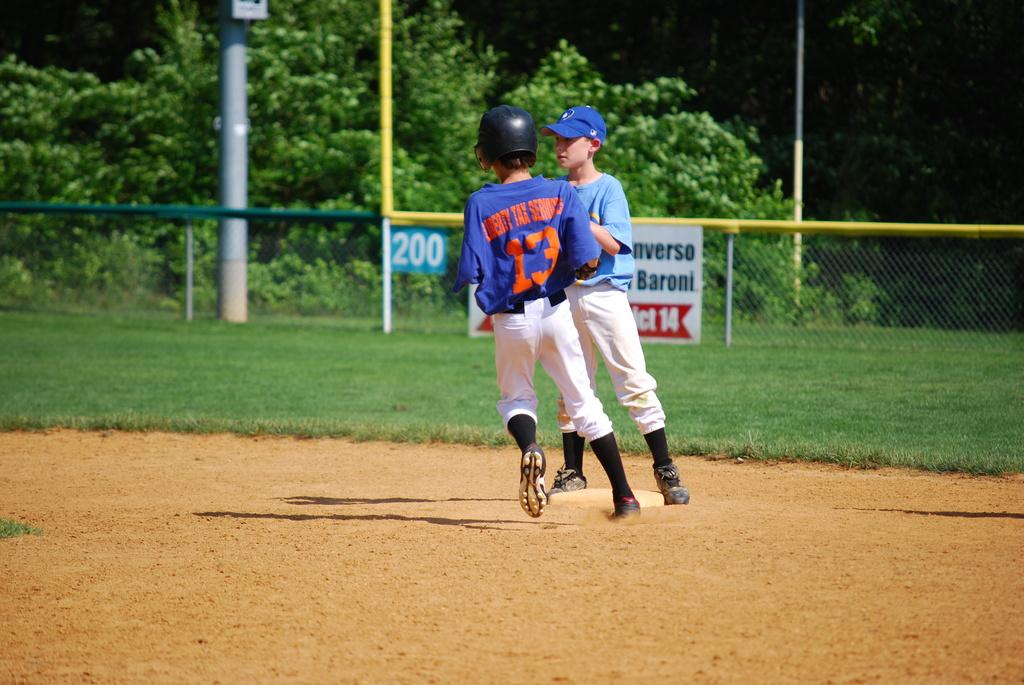Provide a one-sentence caption for the provided image. Baseball player number 13 in a dark blue shirt runs the bases, while a player in a light blue shirt waits at a base to tag him out. 